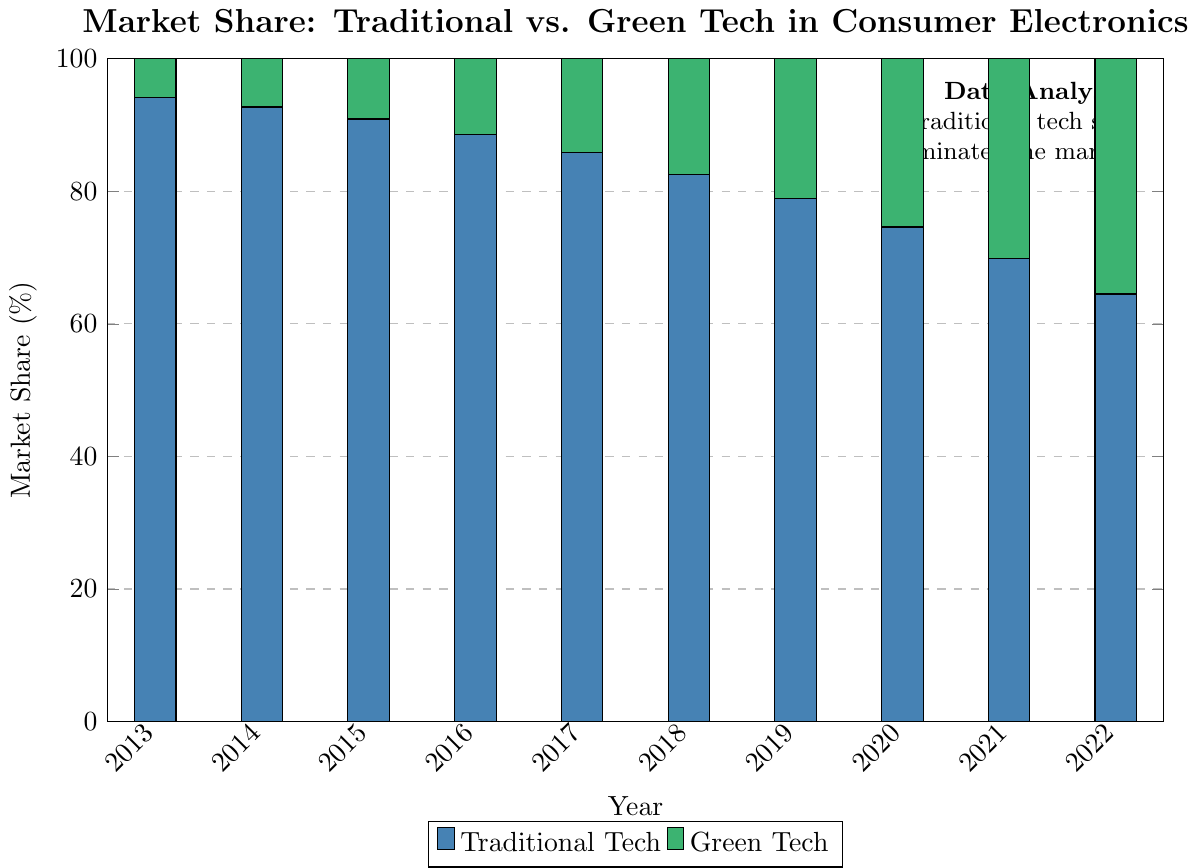What is the trend in the market share of traditional tech from 2013 to 2022? To determine the trend, observe the height of the bars representing traditional tech over the years. The bars decrease in height from 94.2% in 2013 to 64.5% in 2022, indicating a declining trend.
Answer: Declining What is the average market share of green tech from 2013 to 2022? Add the market shares of green tech for each year (5.8 + 7.3 + 9.1 + 11.4 + 14.2 + 17.5 + 21.1 + 25.4 + 30.2 + 35.5 = 177.5) and divide by the number of years (10). So the average is 177.5 / 10 = 17.75%.
Answer: 17.75% In what year did green tech have more than 20% of the market share for the first time? Look at the bars representing green tech and find the year where the market share exceeded 20% for the first time. In 2019, the market share reached 21.1%, which is the first year it surpassed 20%.
Answer: 2019 By how much did the market share of traditional tech decrease from 2013 to 2022? Subtract the market share of traditional tech in 2022 (64.5%) from that in 2013 (94.2%). The difference is 94.2% - 64.5% = 29.7%.
Answer: 29.7% Which year shows the highest increase in market share for green tech compared to the previous year? Calculate the increase for each year by subtracting the previous year's market share from the current year's market share. 2014 (7.3 - 5.8 = 1.5), 2015 (9.1 - 7.3 = 1.8), 2016 (11.4 - 9.1 = 2.3), 2017 (14.2 - 11.4 = 2.8), 2018 (17.5 - 14.2 = 3.3), 2019 (21.1 - 17.5 = 3.6), 2020 (25.4 - 21.1 = 4.3), 2021 (30.2 - 25.4 = 4.8), 2022 (35.5 - 30.2 = 5.3). The highest increase is in 2022, with a 5.3% gain.
Answer: 2022 How does the market share of traditional tech in 2016 compare to that in 2020? Compare the market share values: in 2016 it is 88.6%, and in 2020 it is 74.6%. 88.6% is greater than 74.6%.
Answer: 88.6% > 74.6% In which year did green tech have its lowest market share according to the figure? Identify the smallest value in the green tech bars. The lowest value is in 2013 at 5.8%.
Answer: 2013 What is the market share difference between traditional and green tech in 2022? Subtract the market share of green tech in 2022 (35.5%) from traditional tech (64.5%). The difference is 64.5% - 35.5% = 29%.
Answer: 29% Compare the market share of green tech in 2018 and 2019. Which year experienced greater growth? Calculate the difference: 2019 had 21.1%, and 2018 had 17.5%. The growth is 21.1% - 17.5% = 3.6%. For 2018, it's 17.5% - 14.2% = 3.3%. Thus, 2019 had greater growth at 3.6%.
Answer: 2019 What is the approximate combined market share for both techs in 2017? The sum of the market shares of traditional tech (85.8%) and green tech (14.2%) in 2017 is 85.8% + 14.2% = 100%.
Answer: 100% 